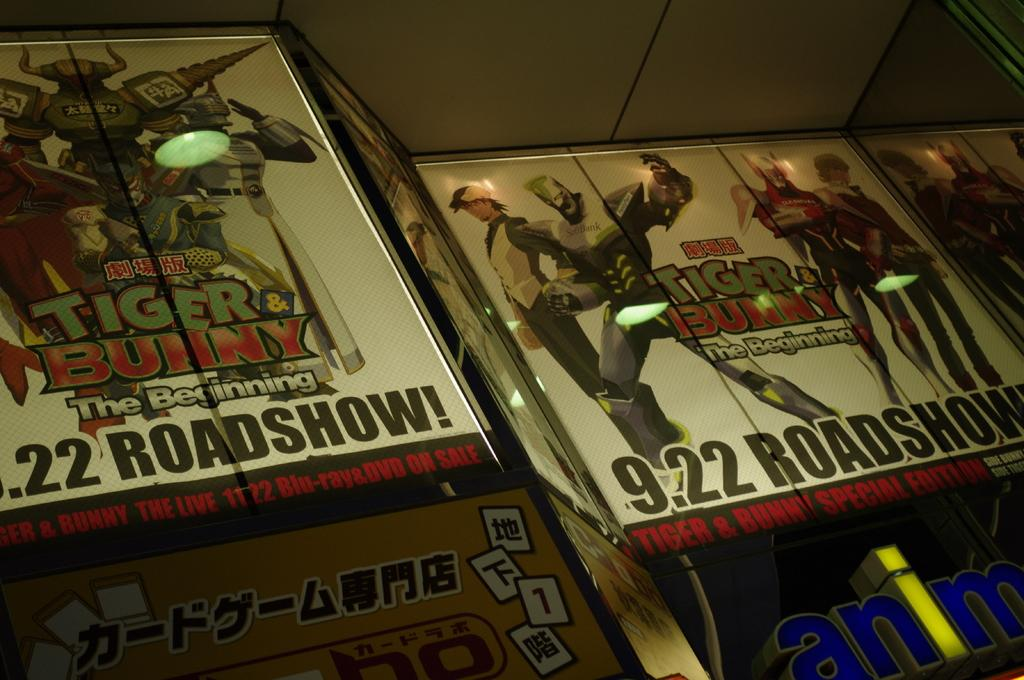<image>
Summarize the visual content of the image. Posters advertising Tiger Bunny, The Beginning with a 9.22 Roadshow. 